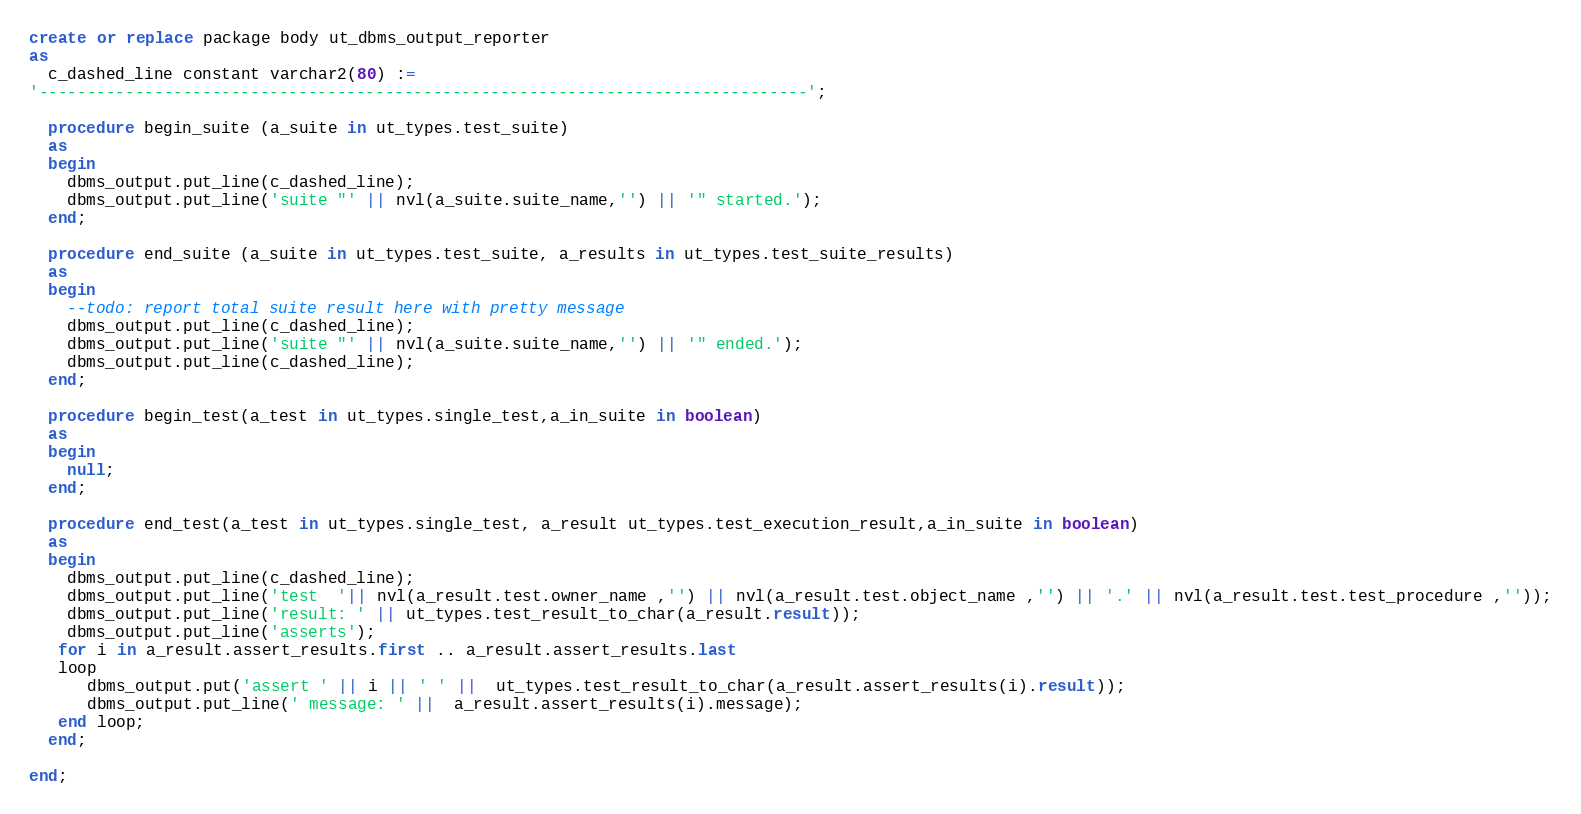<code> <loc_0><loc_0><loc_500><loc_500><_SQL_>create or replace package body ut_dbms_output_reporter
as
  c_dashed_line constant varchar2(80) := 
'--------------------------------------------------------------------------------';

  procedure begin_suite (a_suite in ut_types.test_suite)
  as
  begin
    dbms_output.put_line(c_dashed_line);
    dbms_output.put_line('suite "' || nvl(a_suite.suite_name,'') || '" started.');
  end;
  
  procedure end_suite (a_suite in ut_types.test_suite, a_results in ut_types.test_suite_results)
  as
  begin
    --todo: report total suite result here with pretty message
    dbms_output.put_line(c_dashed_line);   
    dbms_output.put_line('suite "' || nvl(a_suite.suite_name,'') || '" ended.');
    dbms_output.put_line(c_dashed_line);      
  end;  
  
  procedure begin_test(a_test in ut_types.single_test,a_in_suite in boolean)
  as
  begin
    null;
  end;  
  
  procedure end_test(a_test in ut_types.single_test, a_result ut_types.test_execution_result,a_in_suite in boolean)
  as
  begin
    dbms_output.put_line(c_dashed_line);
    dbms_output.put_line('test  '|| nvl(a_result.test.owner_name ,'') || nvl(a_result.test.object_name ,'') || '.' || nvl(a_result.test.test_procedure ,''));
    dbms_output.put_line('result: ' || ut_types.test_result_to_char(a_result.result));
    dbms_output.put_line('asserts');
   for i in a_result.assert_results.first .. a_result.assert_results.last
   loop
      dbms_output.put('assert ' || i || ' ' ||  ut_types.test_result_to_char(a_result.assert_results(i).result));
      dbms_output.put_line(' message: ' ||  a_result.assert_results(i).message);
   end loop;   
  end;  

end;</code> 